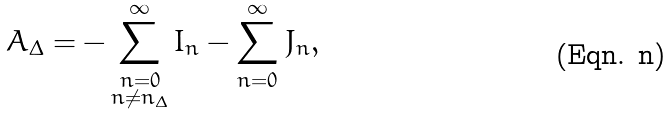<formula> <loc_0><loc_0><loc_500><loc_500>A _ { \Delta } = - \sum _ { \substack { n = 0 \\ n \ne n _ { \Delta } } } ^ { \infty } { I _ { n } } - \sum _ { n = 0 } ^ { \infty } { J _ { n } } ,</formula> 